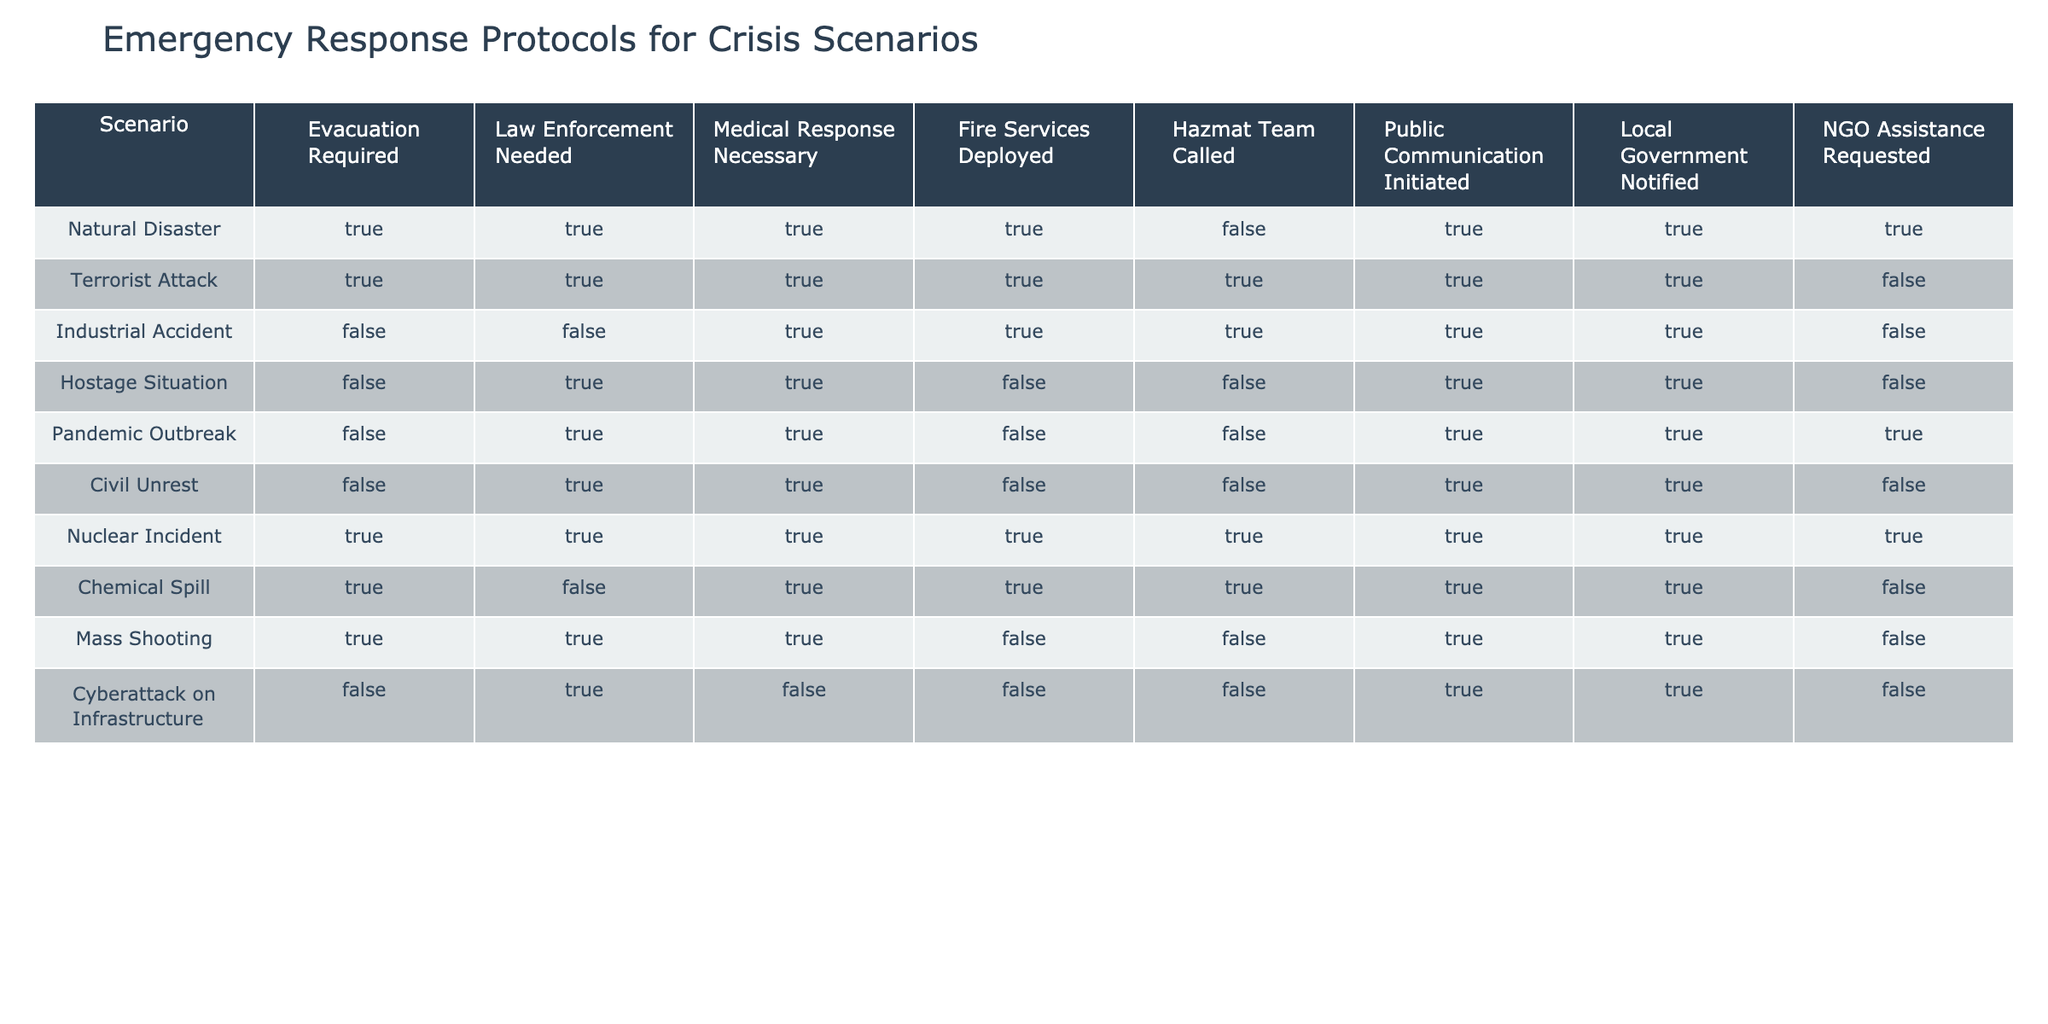What percentage of scenarios require evacuation? There are 10 scenarios in total. The scenarios that require evacuation are Natural Disaster, Terrorist Attack, Nuclear Incident, Chemical Spill, and Mass Shooting. That's 5 out of 10 scenarios. Therefore, the percentage requiring evacuation is (5/10) * 100 = 50%.
Answer: 50% Is law enforcement needed in the event of a pandemic outbreak? By checking the 'Law Enforcement Needed' column for 'Pandemic Outbreak', we can see it is marked TRUE.
Answer: Yes How many scenarios require both medical response and fire services? Looking at the table, the scenarios that have TRUE values for both Medical Response Necessary and Fire Services Deployed are Natural Disaster, Industrial Accident, Nuclear Incident, and Chemical Spill. That gives us a total of 4 scenarios.
Answer: 4 Do any scenarios not require public communication? Checking the 'Public Communication Initiated' column, the scenarios Chemical Spill and Cyberattack on Infrastructure are marked FALSE.
Answer: Yes In how many scenarios is NGO assistance requested? By highlighting the 'NGO Assistance Requested' column, only the scenarios Natural Disaster, Industrial Accident, Pandemic Outbreak, and Civil Unrest show TRUE values. Counting those gives us a total of 4 scenarios requesting NGO assistance.
Answer: 4 What is the total number of scenarios that require both evacuation and law enforcement? We can filter the table for TRUE in 'Evacuation Required' and 'Law Enforcement Needed', which represents the scenarios Natural Disaster, Terrorist Attack, and Nuclear Incident. That sums up to 3 scenarios.
Answer: 3 Which crisis scenarios require hazmat teams? Examining the 'Hazmat Team Called' column, the scenarios that require hazmat teams are Terrorist Attack, Nuclear Incident, Chemical Spill, and Mass Shooting. This provides us with a total of 4 scenarios.
Answer: 4 Is medical response necessary for every scenario except Industrial Accident and Cyberattack on Infrastructure? By assessing the 'Medical Response Necessary' column, we find that all scenarios except Industrial Accident and Cyberattack have TRUE marked for medical response, confirming the statement.
Answer: Yes Which crisis scenario has the highest level of emergency response, as defined by multiple TRUE indicators? The Nuclear Incident has TRUE values across all columns except for NGO Assistance Requested, indicating it has the most extensive emergency response protocol in place among all scenarios.
Answer: Nuclear Incident 